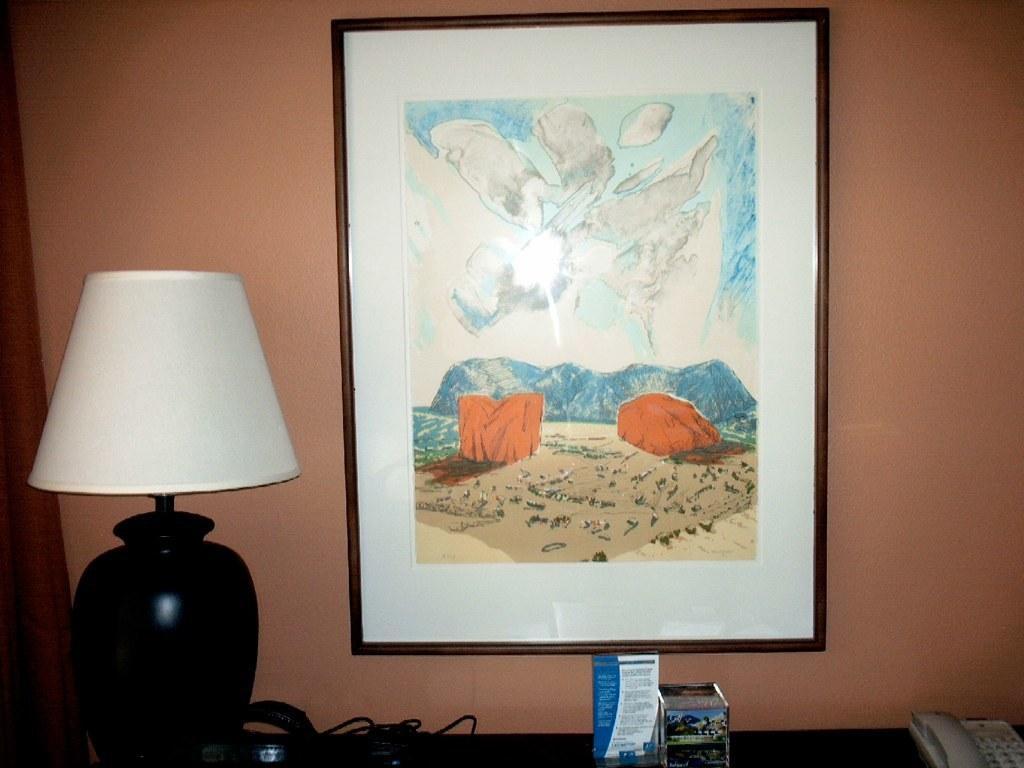Could you give a brief overview of what you see in this image? In the picture I can see a light lamp, telephone and some other objects on a table. I can also see a photo attached to a wall. On this photo I can see a painting of something. 